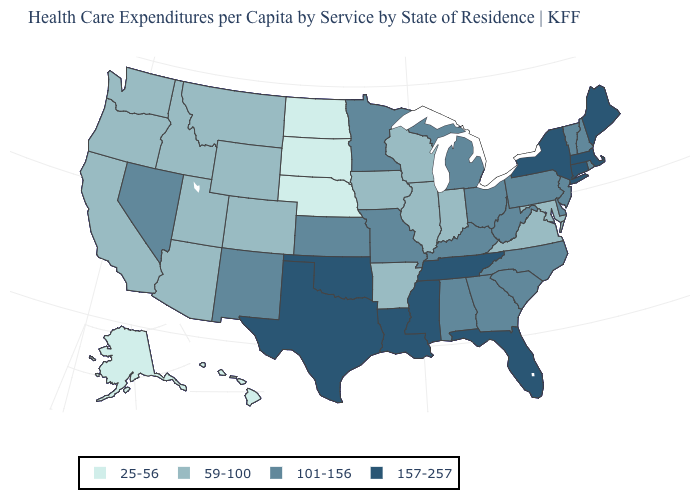Does Connecticut have the highest value in the USA?
Short answer required. Yes. What is the value of Connecticut?
Write a very short answer. 157-257. What is the value of Michigan?
Be succinct. 101-156. What is the highest value in states that border North Dakota?
Answer briefly. 101-156. What is the value of Florida?
Be succinct. 157-257. What is the highest value in the USA?
Keep it brief. 157-257. Does the first symbol in the legend represent the smallest category?
Write a very short answer. Yes. Name the states that have a value in the range 101-156?
Answer briefly. Alabama, Delaware, Georgia, Kansas, Kentucky, Michigan, Minnesota, Missouri, Nevada, New Hampshire, New Jersey, New Mexico, North Carolina, Ohio, Pennsylvania, Rhode Island, South Carolina, Vermont, West Virginia. Does the first symbol in the legend represent the smallest category?
Quick response, please. Yes. Does Pennsylvania have the lowest value in the Northeast?
Concise answer only. Yes. Among the states that border Montana , does Wyoming have the lowest value?
Short answer required. No. Among the states that border Georgia , does Florida have the lowest value?
Write a very short answer. No. What is the lowest value in the USA?
Quick response, please. 25-56. Name the states that have a value in the range 157-257?
Quick response, please. Connecticut, Florida, Louisiana, Maine, Massachusetts, Mississippi, New York, Oklahoma, Tennessee, Texas. What is the value of Missouri?
Concise answer only. 101-156. 